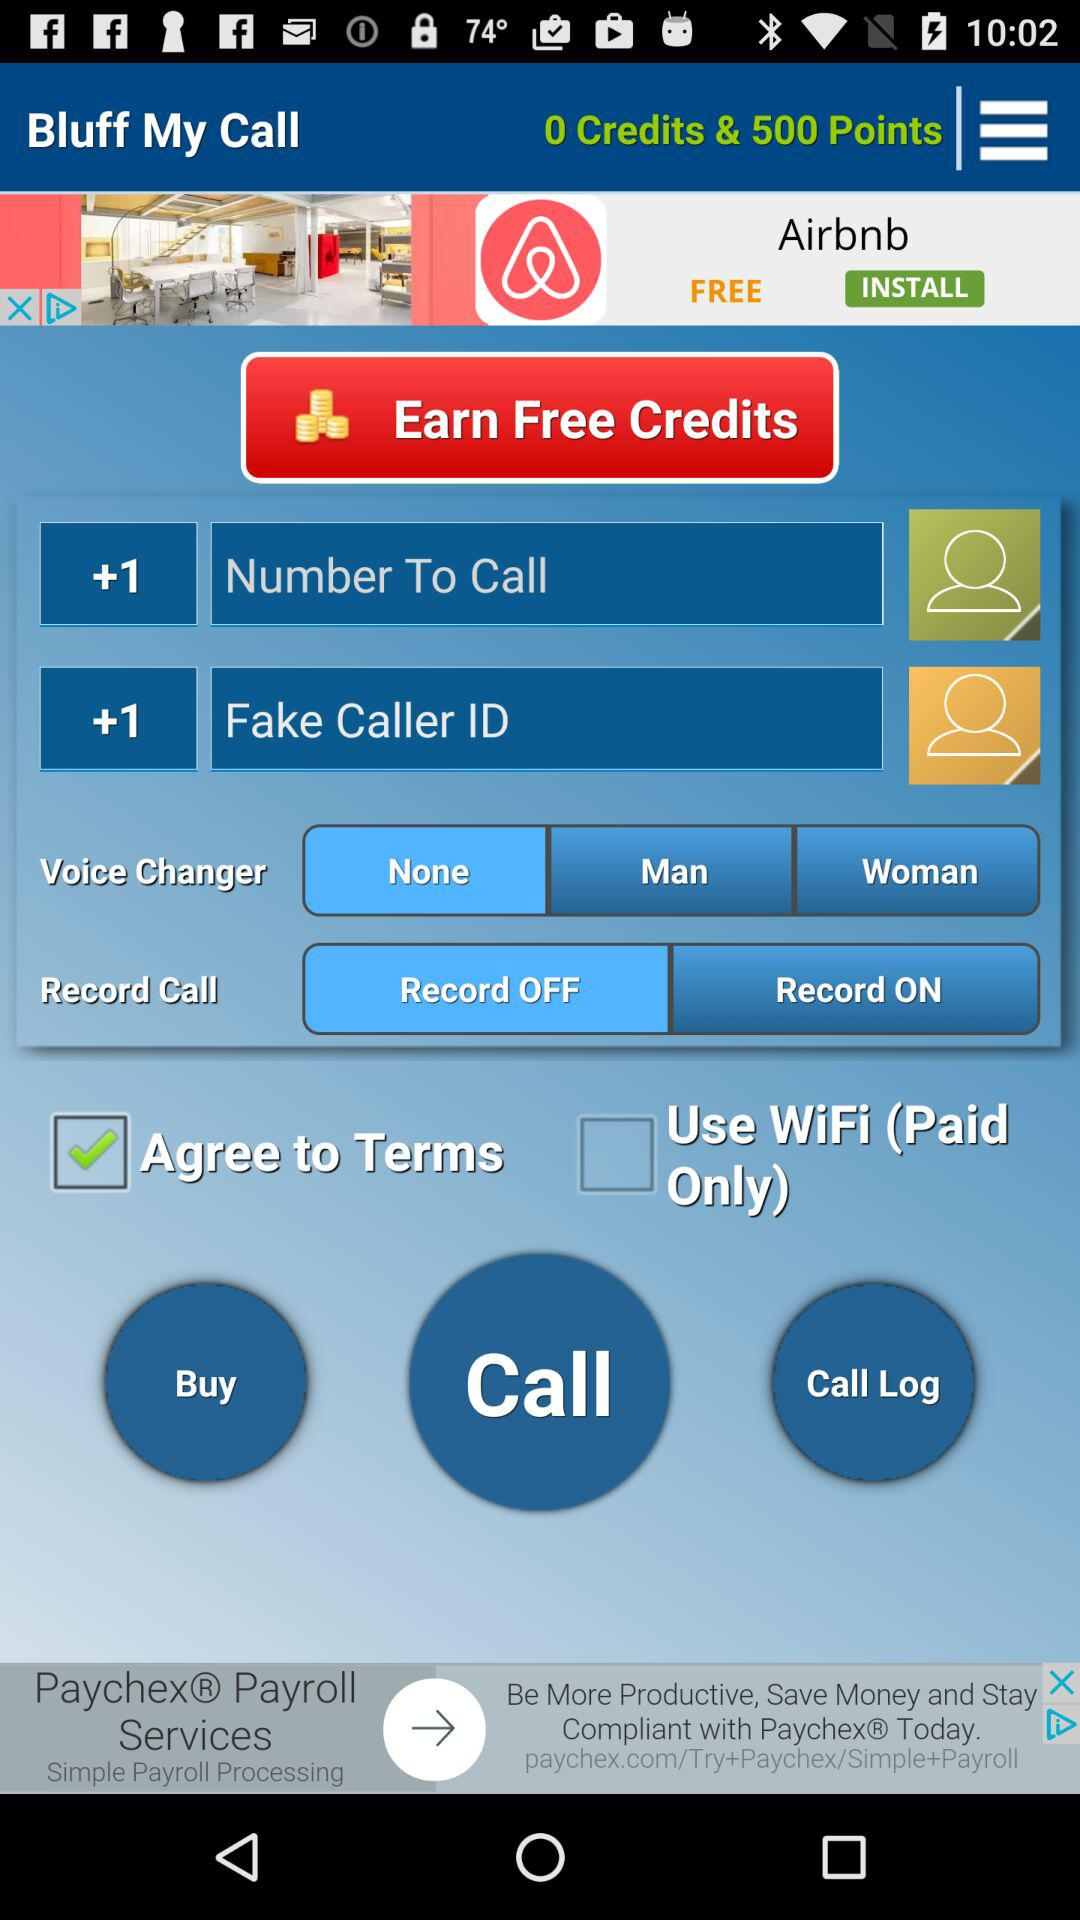How many credits are there? There are zero credits. 